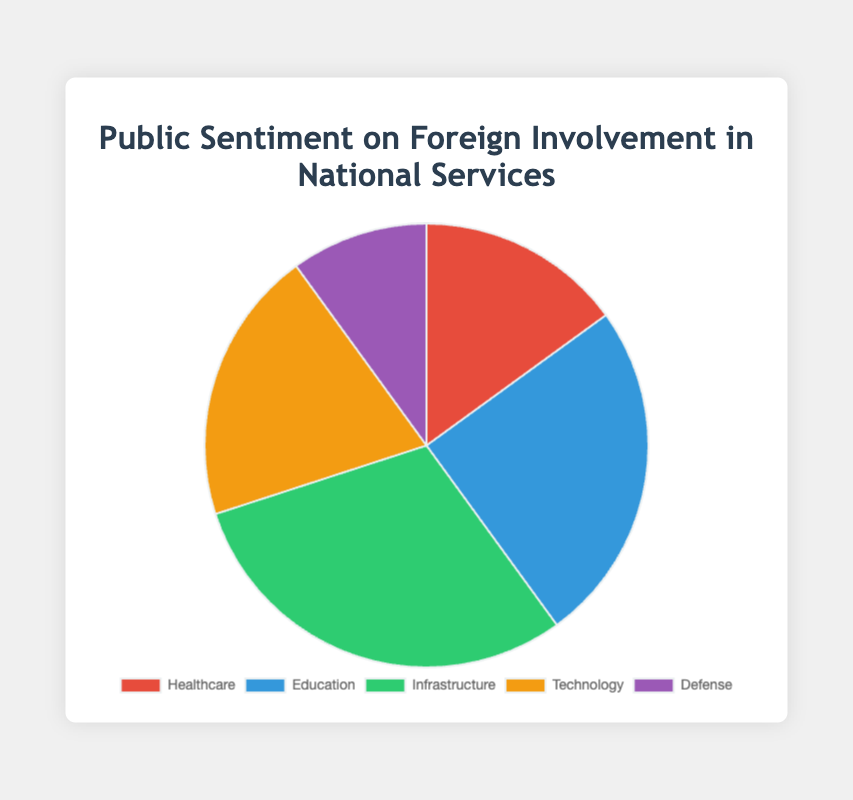Which sector has the highest public sentiment towards foreign involvement? By looking at the pie chart, the sector with the largest slice represents the highest public sentiment. Infrastructure has the largest slice.
Answer: Infrastructure What is the total public sentiment percentage for Healthcare and Education combined? Add the percentages of Healthcare (15) and Education (25). 15 + 25 = 40.
Answer: 40% Which color represents the Technology sector, and what is its percentage? The pie chart uses different colors for each sector. Technology is represented by the orange slice and its percentage is 20%.
Answer: Orange, 20% How does public sentiment towards Foreign Involvement in Healthcare compare to that in Defense? Compare the slices for Healthcare and Defense. Healthcare is 15% and Defense is 10%.
Answer: Healthcare is 5% higher What is the average sentiment percentage across all sectors? Sum the percentages of all sectors: 15 + 25 + 30 + 20 + 10 = 100. Since there are 5 sectors, the average is 100 / 5 = 20.
Answer: 20% What is the difference in sentiment between the sectors with the highest and the lowest percentages? The sector with the highest percentage is Infrastructure (30%), and the lowest is Defense (10%). The difference is 30 - 10 = 20.
Answer: 20% Which two sectors together make up exactly half of the total sentiment? Check combinations of sectors that add up to 50. Education and Infrastructure together: 25 + 30 = 55 (too high). Infrastructure and Healthcare together: 30 + 15 = 45 (too low). Education and Technology: 25 + 20 = 45 (too low). Education and Healthcare: 25 + 15 = 40 (too low). Infrastructure and Technology: 30 + 20 = 50 (correct).
Answer: Infrastructure and Technology Is the public sentiment towards Education greater than that towards Technology and Healthcare combined? Compare 25 (Education) with the combined percentage of Technology and Healthcare: 20 + 15 = 35.
Answer: No What is the complement of public sentiment towards Infrastructure? Subtract the Infrastructure percentage from 100: 100 - 30 = 70.
Answer: 70% 